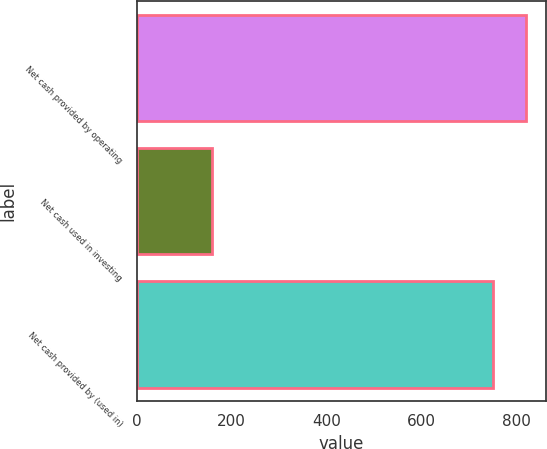Convert chart. <chart><loc_0><loc_0><loc_500><loc_500><bar_chart><fcel>Net cash provided by operating<fcel>Net cash used in investing<fcel>Net cash provided by (used in)<nl><fcel>821.2<fcel>158.5<fcel>751.1<nl></chart> 